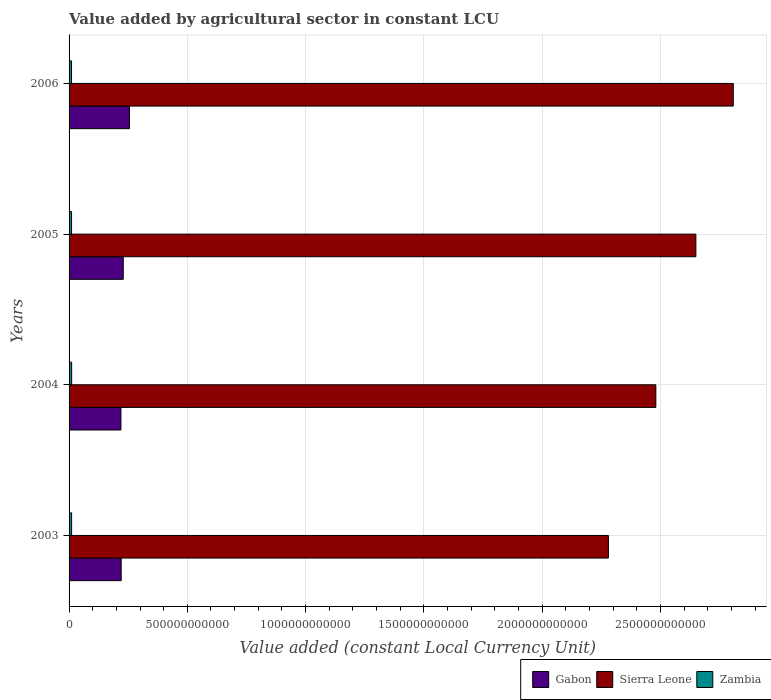How many groups of bars are there?
Provide a short and direct response. 4. Are the number of bars per tick equal to the number of legend labels?
Offer a terse response. Yes. How many bars are there on the 1st tick from the top?
Offer a very short reply. 3. In how many cases, is the number of bars for a given year not equal to the number of legend labels?
Your response must be concise. 0. What is the value added by agricultural sector in Zambia in 2003?
Your answer should be compact. 1.07e+1. Across all years, what is the maximum value added by agricultural sector in Zambia?
Your answer should be very brief. 1.09e+1. Across all years, what is the minimum value added by agricultural sector in Zambia?
Provide a succinct answer. 1.03e+1. In which year was the value added by agricultural sector in Sierra Leone maximum?
Offer a very short reply. 2006. What is the total value added by agricultural sector in Zambia in the graph?
Ensure brevity in your answer.  4.24e+1. What is the difference between the value added by agricultural sector in Sierra Leone in 2003 and that in 2004?
Ensure brevity in your answer.  -2.00e+11. What is the difference between the value added by agricultural sector in Zambia in 2006 and the value added by agricultural sector in Sierra Leone in 2005?
Make the answer very short. -2.64e+12. What is the average value added by agricultural sector in Zambia per year?
Give a very brief answer. 1.06e+1. In the year 2006, what is the difference between the value added by agricultural sector in Gabon and value added by agricultural sector in Zambia?
Give a very brief answer. 2.45e+11. In how many years, is the value added by agricultural sector in Zambia greater than 1300000000000 LCU?
Keep it short and to the point. 0. What is the ratio of the value added by agricultural sector in Gabon in 2004 to that in 2005?
Your answer should be very brief. 0.96. What is the difference between the highest and the second highest value added by agricultural sector in Sierra Leone?
Provide a succinct answer. 1.58e+11. What is the difference between the highest and the lowest value added by agricultural sector in Gabon?
Offer a very short reply. 3.61e+1. In how many years, is the value added by agricultural sector in Sierra Leone greater than the average value added by agricultural sector in Sierra Leone taken over all years?
Give a very brief answer. 2. Is the sum of the value added by agricultural sector in Gabon in 2003 and 2006 greater than the maximum value added by agricultural sector in Zambia across all years?
Give a very brief answer. Yes. What does the 2nd bar from the top in 2006 represents?
Make the answer very short. Sierra Leone. What does the 1st bar from the bottom in 2004 represents?
Provide a succinct answer. Gabon. How many bars are there?
Provide a succinct answer. 12. What is the difference between two consecutive major ticks on the X-axis?
Make the answer very short. 5.00e+11. Are the values on the major ticks of X-axis written in scientific E-notation?
Offer a terse response. No. Does the graph contain grids?
Your response must be concise. Yes. What is the title of the graph?
Provide a succinct answer. Value added by agricultural sector in constant LCU. Does "Sierra Leone" appear as one of the legend labels in the graph?
Your response must be concise. Yes. What is the label or title of the X-axis?
Keep it short and to the point. Value added (constant Local Currency Unit). What is the label or title of the Y-axis?
Offer a terse response. Years. What is the Value added (constant Local Currency Unit) of Gabon in 2003?
Offer a very short reply. 2.20e+11. What is the Value added (constant Local Currency Unit) of Sierra Leone in 2003?
Provide a short and direct response. 2.28e+12. What is the Value added (constant Local Currency Unit) of Zambia in 2003?
Offer a terse response. 1.07e+1. What is the Value added (constant Local Currency Unit) of Gabon in 2004?
Your answer should be very brief. 2.19e+11. What is the Value added (constant Local Currency Unit) in Sierra Leone in 2004?
Provide a short and direct response. 2.48e+12. What is the Value added (constant Local Currency Unit) in Zambia in 2004?
Make the answer very short. 1.09e+1. What is the Value added (constant Local Currency Unit) of Gabon in 2005?
Give a very brief answer. 2.29e+11. What is the Value added (constant Local Currency Unit) of Sierra Leone in 2005?
Your response must be concise. 2.65e+12. What is the Value added (constant Local Currency Unit) of Zambia in 2005?
Your answer should be very brief. 1.05e+1. What is the Value added (constant Local Currency Unit) of Gabon in 2006?
Make the answer very short. 2.55e+11. What is the Value added (constant Local Currency Unit) in Sierra Leone in 2006?
Your answer should be compact. 2.81e+12. What is the Value added (constant Local Currency Unit) of Zambia in 2006?
Your answer should be very brief. 1.03e+1. Across all years, what is the maximum Value added (constant Local Currency Unit) of Gabon?
Ensure brevity in your answer.  2.55e+11. Across all years, what is the maximum Value added (constant Local Currency Unit) of Sierra Leone?
Ensure brevity in your answer.  2.81e+12. Across all years, what is the maximum Value added (constant Local Currency Unit) in Zambia?
Your answer should be very brief. 1.09e+1. Across all years, what is the minimum Value added (constant Local Currency Unit) in Gabon?
Offer a very short reply. 2.19e+11. Across all years, what is the minimum Value added (constant Local Currency Unit) in Sierra Leone?
Provide a short and direct response. 2.28e+12. Across all years, what is the minimum Value added (constant Local Currency Unit) in Zambia?
Give a very brief answer. 1.03e+1. What is the total Value added (constant Local Currency Unit) in Gabon in the graph?
Provide a short and direct response. 9.24e+11. What is the total Value added (constant Local Currency Unit) of Sierra Leone in the graph?
Your response must be concise. 1.02e+13. What is the total Value added (constant Local Currency Unit) in Zambia in the graph?
Your answer should be very brief. 4.24e+1. What is the difference between the Value added (constant Local Currency Unit) of Gabon in 2003 and that in 2004?
Give a very brief answer. 1.13e+09. What is the difference between the Value added (constant Local Currency Unit) of Sierra Leone in 2003 and that in 2004?
Your answer should be very brief. -2.00e+11. What is the difference between the Value added (constant Local Currency Unit) in Zambia in 2003 and that in 2004?
Make the answer very short. -1.71e+08. What is the difference between the Value added (constant Local Currency Unit) in Gabon in 2003 and that in 2005?
Make the answer very short. -8.69e+09. What is the difference between the Value added (constant Local Currency Unit) in Sierra Leone in 2003 and that in 2005?
Your answer should be compact. -3.70e+11. What is the difference between the Value added (constant Local Currency Unit) of Zambia in 2003 and that in 2005?
Provide a short and direct response. 2.16e+08. What is the difference between the Value added (constant Local Currency Unit) of Gabon in 2003 and that in 2006?
Ensure brevity in your answer.  -3.49e+1. What is the difference between the Value added (constant Local Currency Unit) of Sierra Leone in 2003 and that in 2006?
Offer a very short reply. -5.28e+11. What is the difference between the Value added (constant Local Currency Unit) in Zambia in 2003 and that in 2006?
Make the answer very short. 3.65e+08. What is the difference between the Value added (constant Local Currency Unit) of Gabon in 2004 and that in 2005?
Give a very brief answer. -9.81e+09. What is the difference between the Value added (constant Local Currency Unit) in Sierra Leone in 2004 and that in 2005?
Offer a terse response. -1.69e+11. What is the difference between the Value added (constant Local Currency Unit) of Zambia in 2004 and that in 2005?
Provide a short and direct response. 3.86e+08. What is the difference between the Value added (constant Local Currency Unit) in Gabon in 2004 and that in 2006?
Offer a terse response. -3.61e+1. What is the difference between the Value added (constant Local Currency Unit) of Sierra Leone in 2004 and that in 2006?
Provide a short and direct response. -3.27e+11. What is the difference between the Value added (constant Local Currency Unit) in Zambia in 2004 and that in 2006?
Provide a succinct answer. 5.36e+08. What is the difference between the Value added (constant Local Currency Unit) in Gabon in 2005 and that in 2006?
Your response must be concise. -2.62e+1. What is the difference between the Value added (constant Local Currency Unit) in Sierra Leone in 2005 and that in 2006?
Your answer should be compact. -1.58e+11. What is the difference between the Value added (constant Local Currency Unit) of Zambia in 2005 and that in 2006?
Your response must be concise. 1.50e+08. What is the difference between the Value added (constant Local Currency Unit) in Gabon in 2003 and the Value added (constant Local Currency Unit) in Sierra Leone in 2004?
Your answer should be compact. -2.26e+12. What is the difference between the Value added (constant Local Currency Unit) of Gabon in 2003 and the Value added (constant Local Currency Unit) of Zambia in 2004?
Provide a succinct answer. 2.10e+11. What is the difference between the Value added (constant Local Currency Unit) in Sierra Leone in 2003 and the Value added (constant Local Currency Unit) in Zambia in 2004?
Keep it short and to the point. 2.27e+12. What is the difference between the Value added (constant Local Currency Unit) in Gabon in 2003 and the Value added (constant Local Currency Unit) in Sierra Leone in 2005?
Offer a terse response. -2.43e+12. What is the difference between the Value added (constant Local Currency Unit) of Gabon in 2003 and the Value added (constant Local Currency Unit) of Zambia in 2005?
Your response must be concise. 2.10e+11. What is the difference between the Value added (constant Local Currency Unit) of Sierra Leone in 2003 and the Value added (constant Local Currency Unit) of Zambia in 2005?
Provide a succinct answer. 2.27e+12. What is the difference between the Value added (constant Local Currency Unit) in Gabon in 2003 and the Value added (constant Local Currency Unit) in Sierra Leone in 2006?
Offer a very short reply. -2.59e+12. What is the difference between the Value added (constant Local Currency Unit) in Gabon in 2003 and the Value added (constant Local Currency Unit) in Zambia in 2006?
Ensure brevity in your answer.  2.10e+11. What is the difference between the Value added (constant Local Currency Unit) in Sierra Leone in 2003 and the Value added (constant Local Currency Unit) in Zambia in 2006?
Give a very brief answer. 2.27e+12. What is the difference between the Value added (constant Local Currency Unit) of Gabon in 2004 and the Value added (constant Local Currency Unit) of Sierra Leone in 2005?
Provide a succinct answer. -2.43e+12. What is the difference between the Value added (constant Local Currency Unit) in Gabon in 2004 and the Value added (constant Local Currency Unit) in Zambia in 2005?
Provide a short and direct response. 2.09e+11. What is the difference between the Value added (constant Local Currency Unit) of Sierra Leone in 2004 and the Value added (constant Local Currency Unit) of Zambia in 2005?
Ensure brevity in your answer.  2.47e+12. What is the difference between the Value added (constant Local Currency Unit) in Gabon in 2004 and the Value added (constant Local Currency Unit) in Sierra Leone in 2006?
Your answer should be compact. -2.59e+12. What is the difference between the Value added (constant Local Currency Unit) in Gabon in 2004 and the Value added (constant Local Currency Unit) in Zambia in 2006?
Make the answer very short. 2.09e+11. What is the difference between the Value added (constant Local Currency Unit) of Sierra Leone in 2004 and the Value added (constant Local Currency Unit) of Zambia in 2006?
Your response must be concise. 2.47e+12. What is the difference between the Value added (constant Local Currency Unit) in Gabon in 2005 and the Value added (constant Local Currency Unit) in Sierra Leone in 2006?
Your answer should be compact. -2.58e+12. What is the difference between the Value added (constant Local Currency Unit) of Gabon in 2005 and the Value added (constant Local Currency Unit) of Zambia in 2006?
Your answer should be compact. 2.19e+11. What is the difference between the Value added (constant Local Currency Unit) in Sierra Leone in 2005 and the Value added (constant Local Currency Unit) in Zambia in 2006?
Provide a succinct answer. 2.64e+12. What is the average Value added (constant Local Currency Unit) of Gabon per year?
Your answer should be compact. 2.31e+11. What is the average Value added (constant Local Currency Unit) in Sierra Leone per year?
Ensure brevity in your answer.  2.55e+12. What is the average Value added (constant Local Currency Unit) of Zambia per year?
Give a very brief answer. 1.06e+1. In the year 2003, what is the difference between the Value added (constant Local Currency Unit) in Gabon and Value added (constant Local Currency Unit) in Sierra Leone?
Offer a very short reply. -2.06e+12. In the year 2003, what is the difference between the Value added (constant Local Currency Unit) in Gabon and Value added (constant Local Currency Unit) in Zambia?
Provide a succinct answer. 2.10e+11. In the year 2003, what is the difference between the Value added (constant Local Currency Unit) of Sierra Leone and Value added (constant Local Currency Unit) of Zambia?
Your response must be concise. 2.27e+12. In the year 2004, what is the difference between the Value added (constant Local Currency Unit) in Gabon and Value added (constant Local Currency Unit) in Sierra Leone?
Give a very brief answer. -2.26e+12. In the year 2004, what is the difference between the Value added (constant Local Currency Unit) of Gabon and Value added (constant Local Currency Unit) of Zambia?
Make the answer very short. 2.08e+11. In the year 2004, what is the difference between the Value added (constant Local Currency Unit) in Sierra Leone and Value added (constant Local Currency Unit) in Zambia?
Offer a very short reply. 2.47e+12. In the year 2005, what is the difference between the Value added (constant Local Currency Unit) of Gabon and Value added (constant Local Currency Unit) of Sierra Leone?
Provide a short and direct response. -2.42e+12. In the year 2005, what is the difference between the Value added (constant Local Currency Unit) in Gabon and Value added (constant Local Currency Unit) in Zambia?
Your answer should be very brief. 2.19e+11. In the year 2005, what is the difference between the Value added (constant Local Currency Unit) in Sierra Leone and Value added (constant Local Currency Unit) in Zambia?
Ensure brevity in your answer.  2.64e+12. In the year 2006, what is the difference between the Value added (constant Local Currency Unit) of Gabon and Value added (constant Local Currency Unit) of Sierra Leone?
Provide a short and direct response. -2.55e+12. In the year 2006, what is the difference between the Value added (constant Local Currency Unit) in Gabon and Value added (constant Local Currency Unit) in Zambia?
Keep it short and to the point. 2.45e+11. In the year 2006, what is the difference between the Value added (constant Local Currency Unit) in Sierra Leone and Value added (constant Local Currency Unit) in Zambia?
Offer a terse response. 2.80e+12. What is the ratio of the Value added (constant Local Currency Unit) of Gabon in 2003 to that in 2004?
Your answer should be compact. 1.01. What is the ratio of the Value added (constant Local Currency Unit) of Sierra Leone in 2003 to that in 2004?
Provide a short and direct response. 0.92. What is the ratio of the Value added (constant Local Currency Unit) of Zambia in 2003 to that in 2004?
Your answer should be very brief. 0.98. What is the ratio of the Value added (constant Local Currency Unit) in Gabon in 2003 to that in 2005?
Keep it short and to the point. 0.96. What is the ratio of the Value added (constant Local Currency Unit) of Sierra Leone in 2003 to that in 2005?
Ensure brevity in your answer.  0.86. What is the ratio of the Value added (constant Local Currency Unit) of Zambia in 2003 to that in 2005?
Give a very brief answer. 1.02. What is the ratio of the Value added (constant Local Currency Unit) of Gabon in 2003 to that in 2006?
Your answer should be compact. 0.86. What is the ratio of the Value added (constant Local Currency Unit) of Sierra Leone in 2003 to that in 2006?
Provide a succinct answer. 0.81. What is the ratio of the Value added (constant Local Currency Unit) in Zambia in 2003 to that in 2006?
Provide a succinct answer. 1.04. What is the ratio of the Value added (constant Local Currency Unit) of Gabon in 2004 to that in 2005?
Provide a succinct answer. 0.96. What is the ratio of the Value added (constant Local Currency Unit) in Sierra Leone in 2004 to that in 2005?
Make the answer very short. 0.94. What is the ratio of the Value added (constant Local Currency Unit) of Zambia in 2004 to that in 2005?
Make the answer very short. 1.04. What is the ratio of the Value added (constant Local Currency Unit) of Gabon in 2004 to that in 2006?
Offer a terse response. 0.86. What is the ratio of the Value added (constant Local Currency Unit) of Sierra Leone in 2004 to that in 2006?
Give a very brief answer. 0.88. What is the ratio of the Value added (constant Local Currency Unit) of Zambia in 2004 to that in 2006?
Your answer should be very brief. 1.05. What is the ratio of the Value added (constant Local Currency Unit) in Gabon in 2005 to that in 2006?
Ensure brevity in your answer.  0.9. What is the ratio of the Value added (constant Local Currency Unit) in Sierra Leone in 2005 to that in 2006?
Your answer should be compact. 0.94. What is the ratio of the Value added (constant Local Currency Unit) in Zambia in 2005 to that in 2006?
Provide a short and direct response. 1.01. What is the difference between the highest and the second highest Value added (constant Local Currency Unit) in Gabon?
Your answer should be compact. 2.62e+1. What is the difference between the highest and the second highest Value added (constant Local Currency Unit) in Sierra Leone?
Offer a terse response. 1.58e+11. What is the difference between the highest and the second highest Value added (constant Local Currency Unit) in Zambia?
Your answer should be very brief. 1.71e+08. What is the difference between the highest and the lowest Value added (constant Local Currency Unit) of Gabon?
Your response must be concise. 3.61e+1. What is the difference between the highest and the lowest Value added (constant Local Currency Unit) of Sierra Leone?
Provide a succinct answer. 5.28e+11. What is the difference between the highest and the lowest Value added (constant Local Currency Unit) in Zambia?
Ensure brevity in your answer.  5.36e+08. 